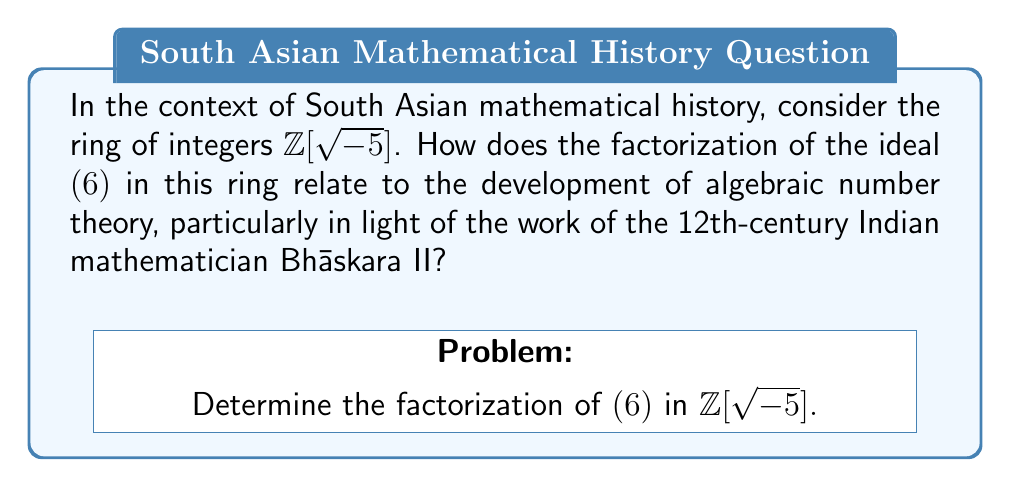Help me with this question. 1) First, recall that $\mathbb{Z}[\sqrt{-5}]$ is the ring of integers of the quadratic field $\mathbb{Q}(\sqrt{-5})$.

2) In $\mathbb{Z}[\sqrt{-5}]$, we can factor 6 as:
   $6 = 2 \cdot 3$
   $6 = (1 + \sqrt{-5})(1 - \sqrt{-5})$

3) This non-unique factorization is reminiscent of the problems Bhāskara II encountered in his work on Diophantine equations, particularly in his text "Bījagaṇita".

4) To understand the ideal factorization, we need to consider the prime ideals in $\mathbb{Z}[\sqrt{-5}]$:
   $(2, 1 + \sqrt{-5})$
   $(3, 1 + \sqrt{-5})$
   $(3, 1 - \sqrt{-5})$

5) The ideal $(6)$ can be factored as:
   $(6) = (2, 1 + \sqrt{-5})^2 \cdot (3, 1 + \sqrt{-5}) \cdot (3, 1 - \sqrt{-5})$

6) This unique factorization of ideals, in contrast to the non-unique factorization of elements, illustrates the power of ideal theory in resolving issues in algebraic number theory.

7) Bhāskara II's work, while not explicitly dealing with ideals, laid groundwork for understanding complex number systems and equations that would later be formalized through ideal theory.

8) The development of ideal theory in the 19th century by Dedekind and others can be seen as a culmination of efforts to resolve issues first noticed by mathematicians like Bhāskara II in their study of number systems and equations.
Answer: $(6) = (2, 1 + \sqrt{-5})^2 \cdot (3, 1 + \sqrt{-5}) \cdot (3, 1 - \sqrt{-5})$ 